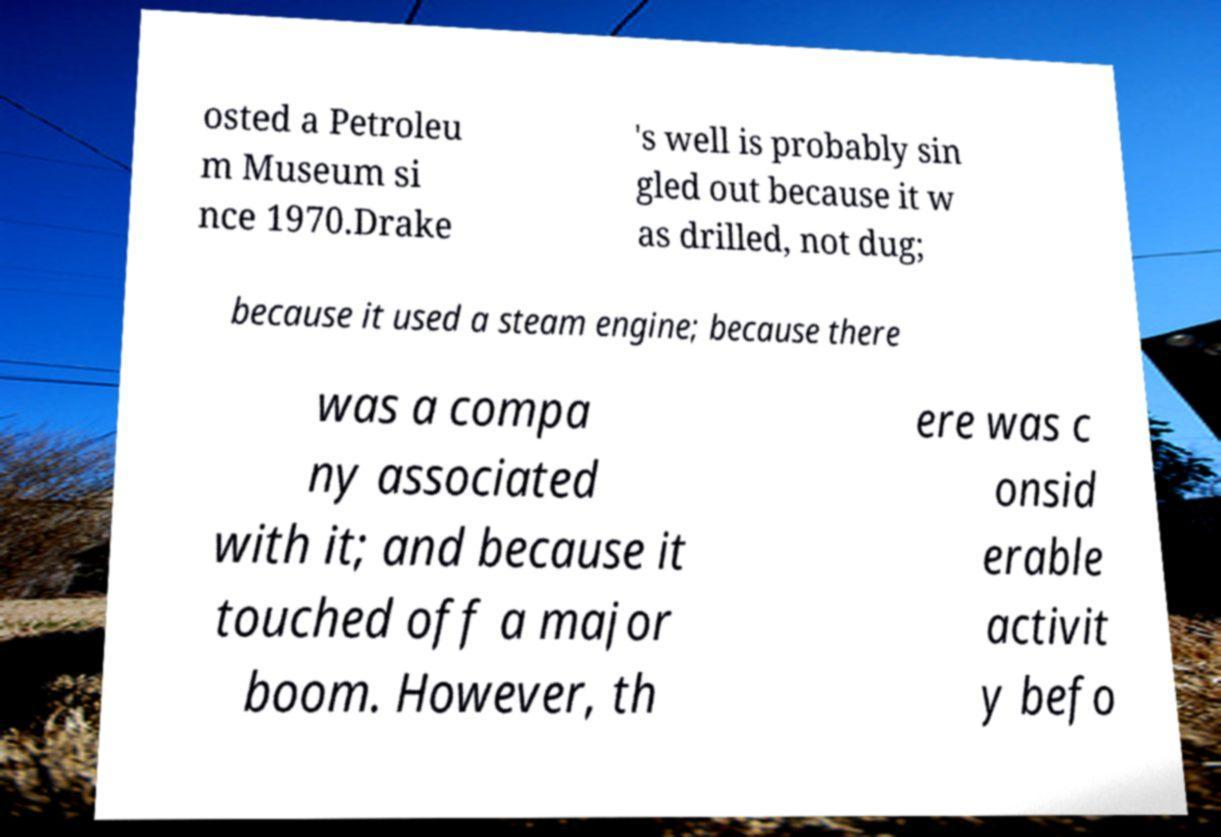Please read and relay the text visible in this image. What does it say? osted a Petroleu m Museum si nce 1970.Drake 's well is probably sin gled out because it w as drilled, not dug; because it used a steam engine; because there was a compa ny associated with it; and because it touched off a major boom. However, th ere was c onsid erable activit y befo 